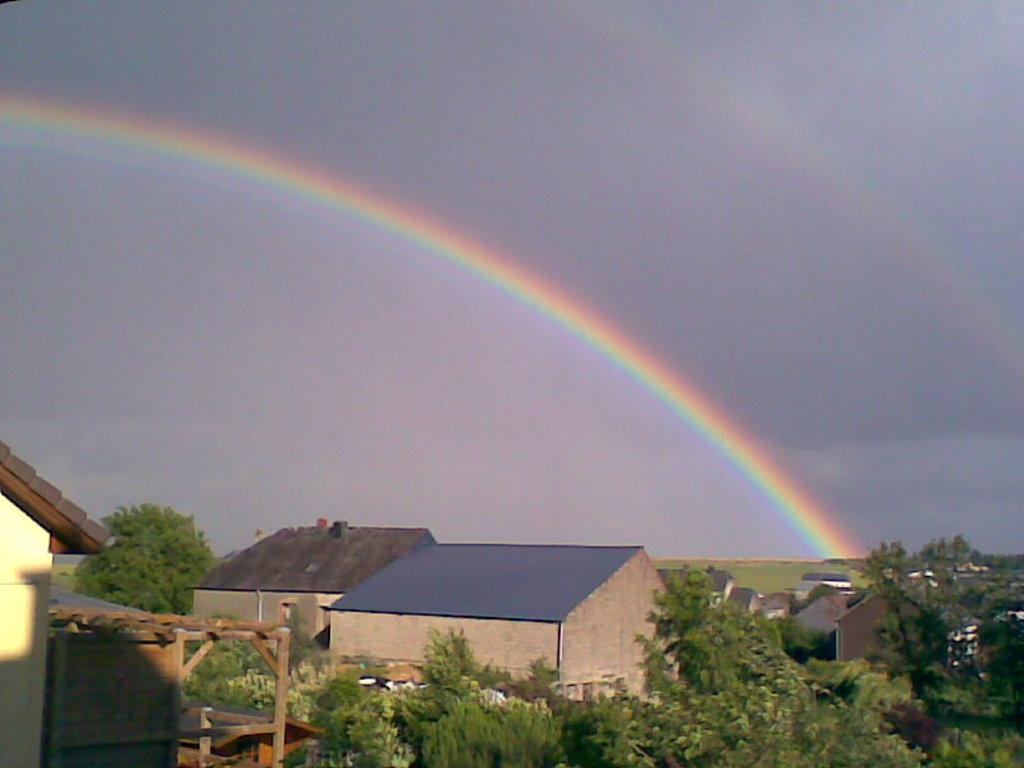What type of structures can be seen in the image? There are buildings in the image. What other natural elements are present in the image? There are trees in the image. What unique feature can be seen in the sky? There is a rainbow in the sky. Can you describe another feature in the sky? There is another rainbow in the backdrop. How would you describe the overall weather condition in the image? The sky is cloudy. What type of quartz can be seen in the image? There is no quartz present in the image. Can you describe the trick performed by the rainbow in the image? There is no trick being performed by the rainbow in the image; it is a natural atmospheric phenomenon. 